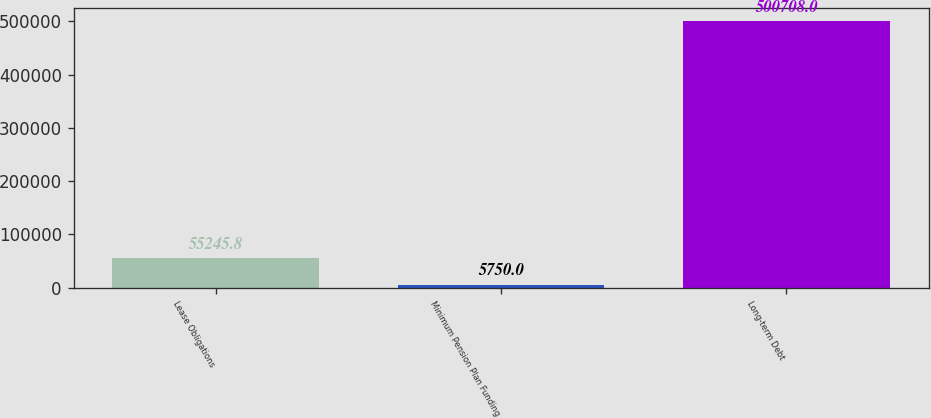Convert chart to OTSL. <chart><loc_0><loc_0><loc_500><loc_500><bar_chart><fcel>Lease Obligations<fcel>Minimum Pension Plan Funding<fcel>Long-term Debt<nl><fcel>55245.8<fcel>5750<fcel>500708<nl></chart> 